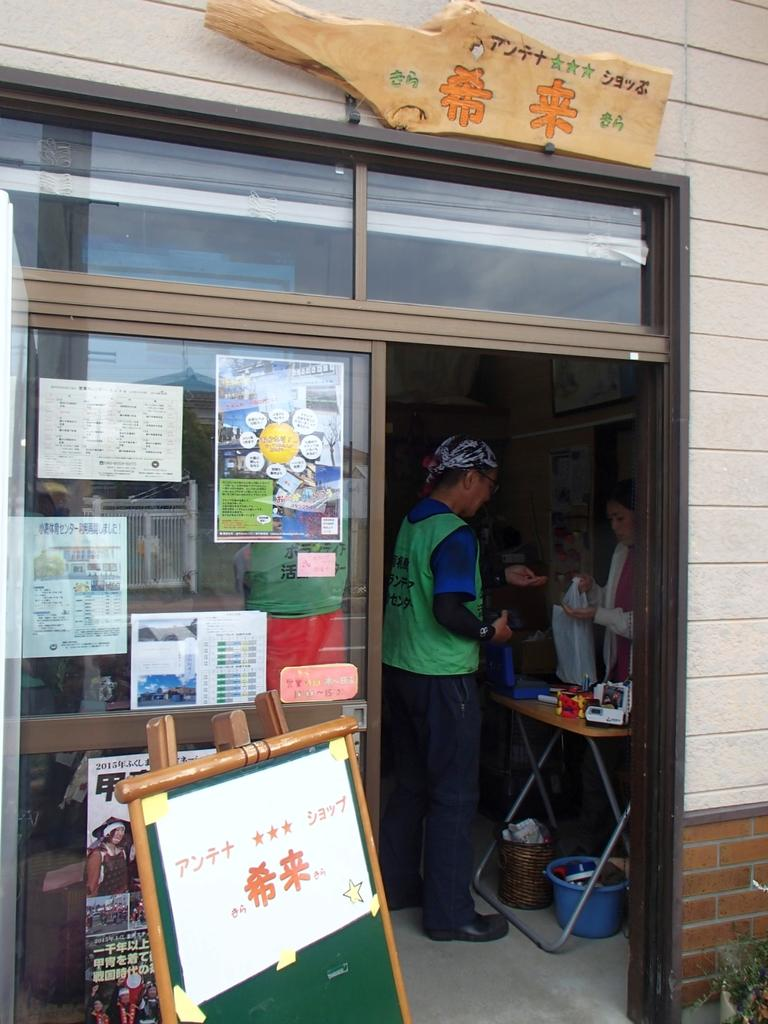How many people are in the image? There are persons in the image, but the exact number is not specified. What can be seen on the wall in the image? There are posters on the wall in the image. What is the background of the image? The background of the image includes a wall with posters on it. How many cats are visible in the image? There are no cats present in the image. What type of representative is shown in the image? There is no representative shown in the image; it features persons and posters on a wall. 